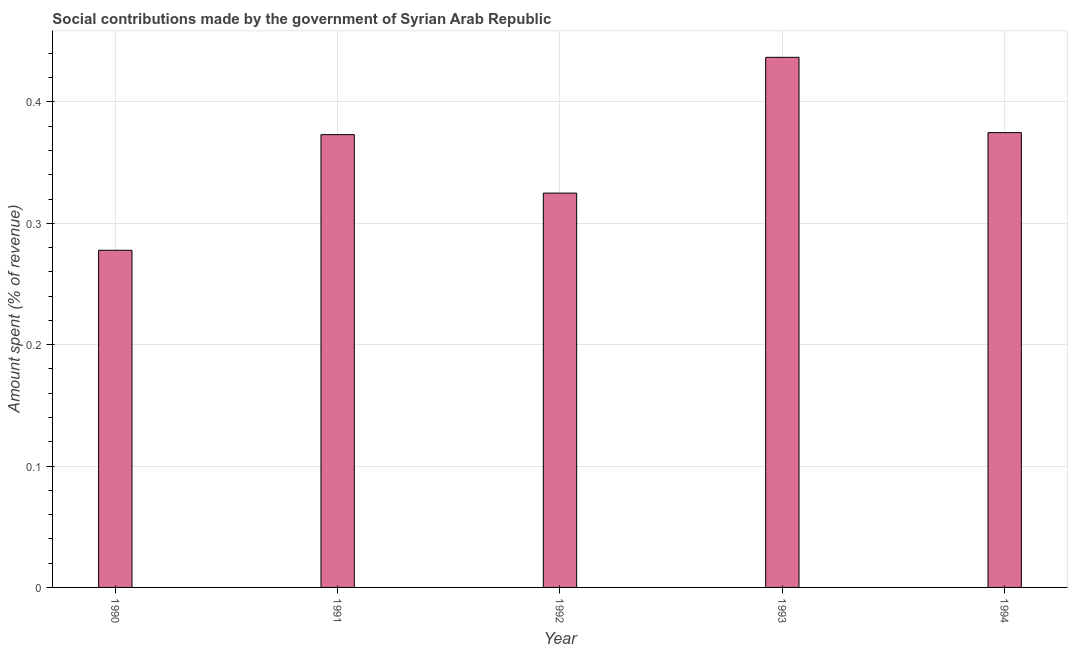What is the title of the graph?
Offer a very short reply. Social contributions made by the government of Syrian Arab Republic. What is the label or title of the X-axis?
Your answer should be compact. Year. What is the label or title of the Y-axis?
Ensure brevity in your answer.  Amount spent (% of revenue). What is the amount spent in making social contributions in 1992?
Make the answer very short. 0.32. Across all years, what is the maximum amount spent in making social contributions?
Offer a very short reply. 0.44. Across all years, what is the minimum amount spent in making social contributions?
Ensure brevity in your answer.  0.28. What is the sum of the amount spent in making social contributions?
Your answer should be compact. 1.79. What is the difference between the amount spent in making social contributions in 1991 and 1992?
Keep it short and to the point. 0.05. What is the average amount spent in making social contributions per year?
Your answer should be very brief. 0.36. What is the median amount spent in making social contributions?
Keep it short and to the point. 0.37. What is the ratio of the amount spent in making social contributions in 1992 to that in 1993?
Ensure brevity in your answer.  0.74. Is the amount spent in making social contributions in 1992 less than that in 1993?
Provide a short and direct response. Yes. Is the difference between the amount spent in making social contributions in 1991 and 1994 greater than the difference between any two years?
Provide a short and direct response. No. What is the difference between the highest and the second highest amount spent in making social contributions?
Keep it short and to the point. 0.06. Is the sum of the amount spent in making social contributions in 1990 and 1994 greater than the maximum amount spent in making social contributions across all years?
Your response must be concise. Yes. What is the difference between the highest and the lowest amount spent in making social contributions?
Provide a succinct answer. 0.16. In how many years, is the amount spent in making social contributions greater than the average amount spent in making social contributions taken over all years?
Your answer should be compact. 3. How many bars are there?
Make the answer very short. 5. What is the difference between two consecutive major ticks on the Y-axis?
Give a very brief answer. 0.1. What is the Amount spent (% of revenue) of 1990?
Give a very brief answer. 0.28. What is the Amount spent (% of revenue) of 1991?
Make the answer very short. 0.37. What is the Amount spent (% of revenue) in 1992?
Your response must be concise. 0.32. What is the Amount spent (% of revenue) of 1993?
Offer a very short reply. 0.44. What is the Amount spent (% of revenue) in 1994?
Your answer should be compact. 0.37. What is the difference between the Amount spent (% of revenue) in 1990 and 1991?
Your answer should be very brief. -0.1. What is the difference between the Amount spent (% of revenue) in 1990 and 1992?
Ensure brevity in your answer.  -0.05. What is the difference between the Amount spent (% of revenue) in 1990 and 1993?
Your answer should be compact. -0.16. What is the difference between the Amount spent (% of revenue) in 1990 and 1994?
Keep it short and to the point. -0.1. What is the difference between the Amount spent (% of revenue) in 1991 and 1992?
Offer a terse response. 0.05. What is the difference between the Amount spent (% of revenue) in 1991 and 1993?
Provide a short and direct response. -0.06. What is the difference between the Amount spent (% of revenue) in 1991 and 1994?
Offer a very short reply. -0. What is the difference between the Amount spent (% of revenue) in 1992 and 1993?
Your response must be concise. -0.11. What is the difference between the Amount spent (% of revenue) in 1992 and 1994?
Provide a short and direct response. -0.05. What is the difference between the Amount spent (% of revenue) in 1993 and 1994?
Offer a terse response. 0.06. What is the ratio of the Amount spent (% of revenue) in 1990 to that in 1991?
Provide a short and direct response. 0.74. What is the ratio of the Amount spent (% of revenue) in 1990 to that in 1992?
Your answer should be compact. 0.85. What is the ratio of the Amount spent (% of revenue) in 1990 to that in 1993?
Provide a short and direct response. 0.64. What is the ratio of the Amount spent (% of revenue) in 1990 to that in 1994?
Your answer should be compact. 0.74. What is the ratio of the Amount spent (% of revenue) in 1991 to that in 1992?
Your response must be concise. 1.15. What is the ratio of the Amount spent (% of revenue) in 1991 to that in 1993?
Offer a very short reply. 0.85. What is the ratio of the Amount spent (% of revenue) in 1991 to that in 1994?
Offer a very short reply. 1. What is the ratio of the Amount spent (% of revenue) in 1992 to that in 1993?
Offer a terse response. 0.74. What is the ratio of the Amount spent (% of revenue) in 1992 to that in 1994?
Your response must be concise. 0.87. What is the ratio of the Amount spent (% of revenue) in 1993 to that in 1994?
Provide a succinct answer. 1.17. 